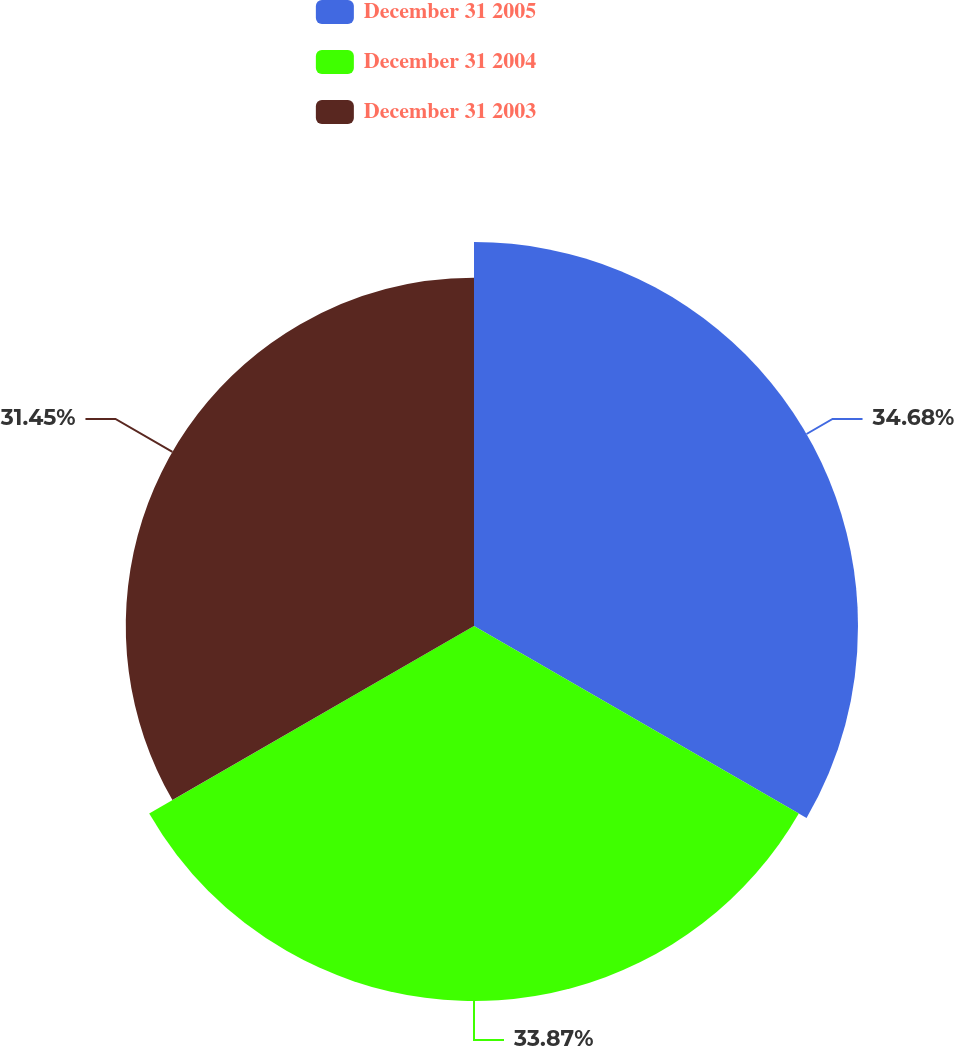Convert chart. <chart><loc_0><loc_0><loc_500><loc_500><pie_chart><fcel>December 31 2005<fcel>December 31 2004<fcel>December 31 2003<nl><fcel>34.68%<fcel>33.87%<fcel>31.45%<nl></chart> 